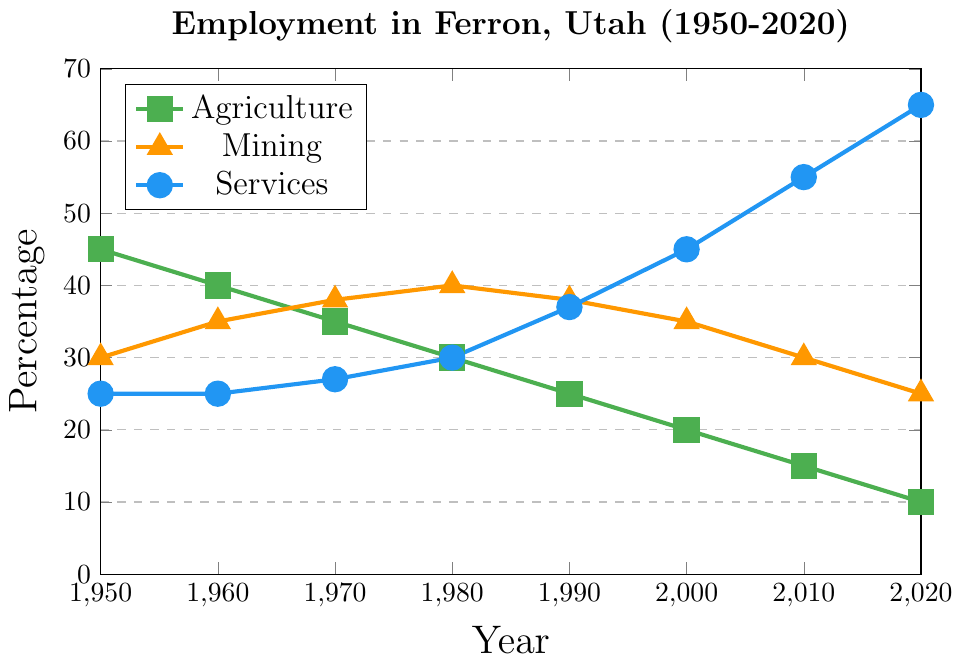What's the overall trend in the percentage of residents employed in agriculture from 1950 to 2020? The percentage of residents employed in agriculture consistently decreased over the years from 45% in 1950 to 10% in 2020.
Answer: Decreasing Which industry had the highest percentage of employment in 2020? In 2020, the services industry had the highest percentage of employment at 65%, compared to 25% in mining and 10% in agriculture.
Answer: Services By how much did the percentage of residents employed in the services industry increase between 1980 and 2020? The percentage in the services industry increased from 30% in 1980 to 65% in 2020. The increase is 65% - 30% = 35%.
Answer: 35% In which decade did the mining industry reach its peak employment percentage, and what was the percentage? Mining industry employment peaked in the 1980s with a percentage of 40%. This is the highest value observed in the mining data across all decades.
Answer: 1980s, 40% How do the percentages of employment in agriculture and mining compare in 1960? In 1960, the percentages of employment were 40% for agriculture and 35% for mining. Agriculture had a higher percentage than mining.
Answer: Agriculture higher What’s the total percentage of residents employed in all three industries in 2000? The total percentage is the sum of the percentages for agriculture (20%), mining (35%), and services (45%) in 2000. Therefore, 20% + 35% + 45% = 100%.
Answer: 100% What color represents the services industry on the plot? The services industry is represented by the color blue on the plot.
Answer: Blue Between which decades did the percentage of residents employed in agriculture decrease the most? The largest decrease happened between 2000 (20%) and 2010 (15%), which is a drop of 5 percentage points.
Answer: 2000-2010 What’s the trend in the mining industry employment between 1970 and 1990? The employment percentage in mining increased from 38% in 1970 to 40% in 1980, then decreased slightly to 38% in 1990. The trend includes an increase followed by stabilization.
Answer: Increase then stabilize If you add the percentages of employment for agriculture, mining, and services in 1990, what do you get? The percentages in 1990 are 25% (agriculture), 38% (mining), and 37% (services). Summing them: 25% + 38% + 37% = 100%.
Answer: 100% 